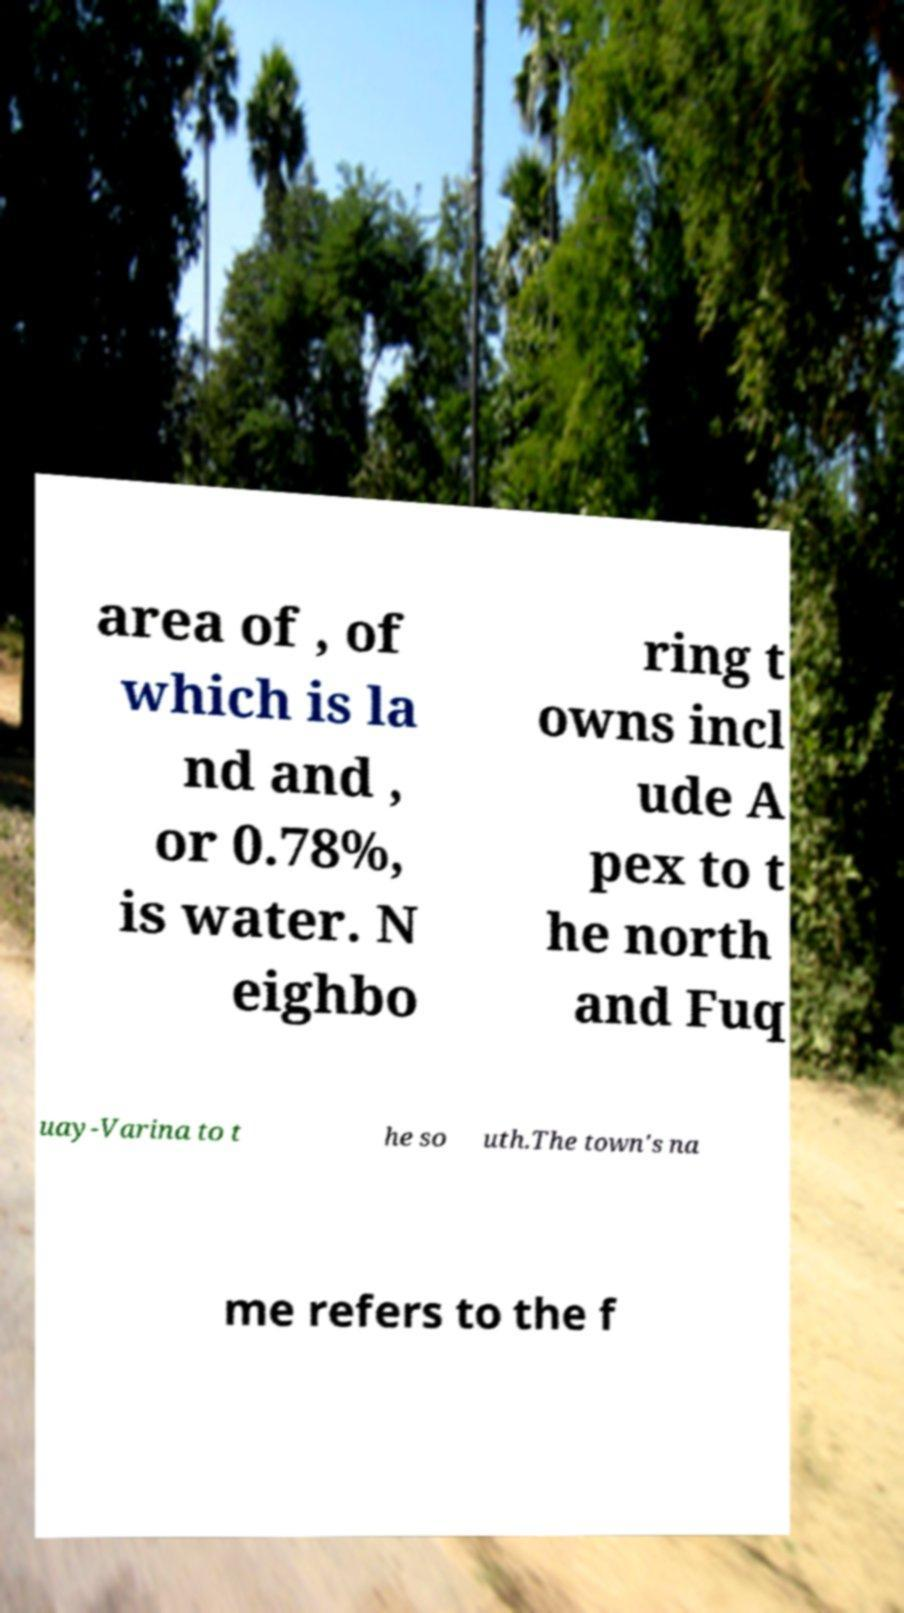I need the written content from this picture converted into text. Can you do that? area of , of which is la nd and , or 0.78%, is water. N eighbo ring t owns incl ude A pex to t he north and Fuq uay-Varina to t he so uth.The town's na me refers to the f 